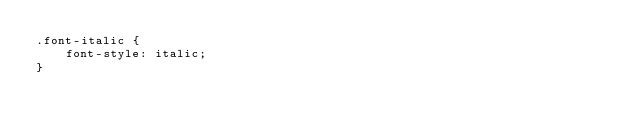Convert code to text. <code><loc_0><loc_0><loc_500><loc_500><_CSS_>.font-italic {
    font-style: italic;
}
</code> 